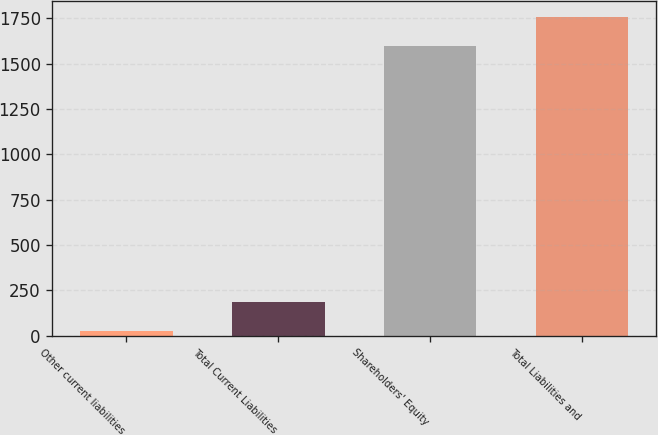Convert chart to OTSL. <chart><loc_0><loc_0><loc_500><loc_500><bar_chart><fcel>Other current liabilities<fcel>Total Current Liabilities<fcel>Shareholders' Equity<fcel>Total Liabilities and<nl><fcel>24<fcel>183.7<fcel>1597<fcel>1756.7<nl></chart> 